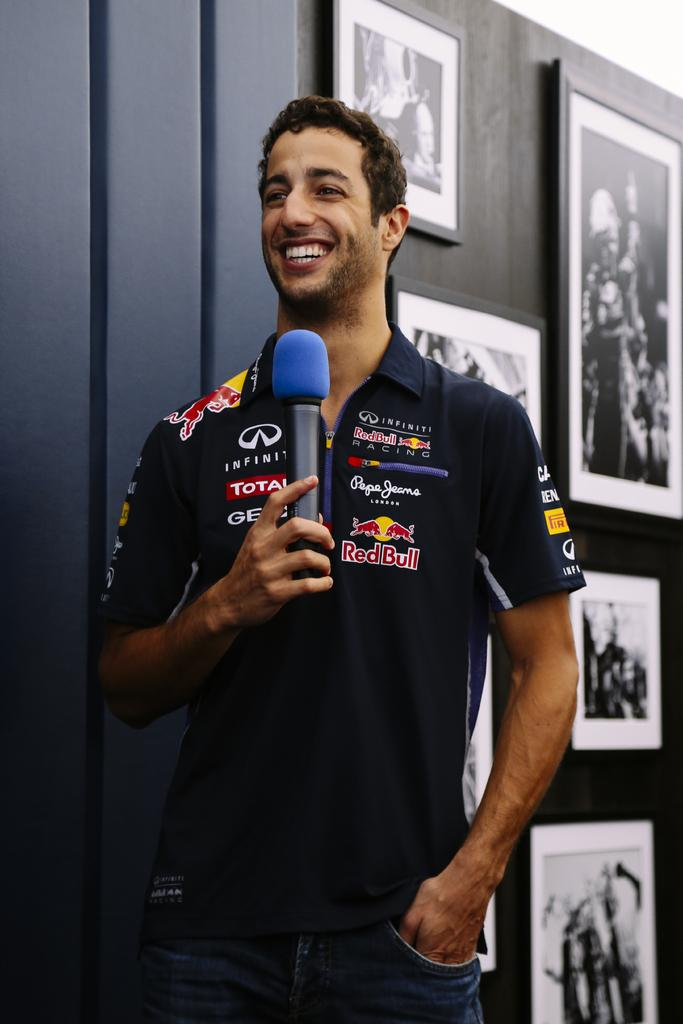Provide a one-sentence caption for the provided image. A man wearing a shirt featuring different companies like RedBull and Infiniti smiles and holds a microphone. 